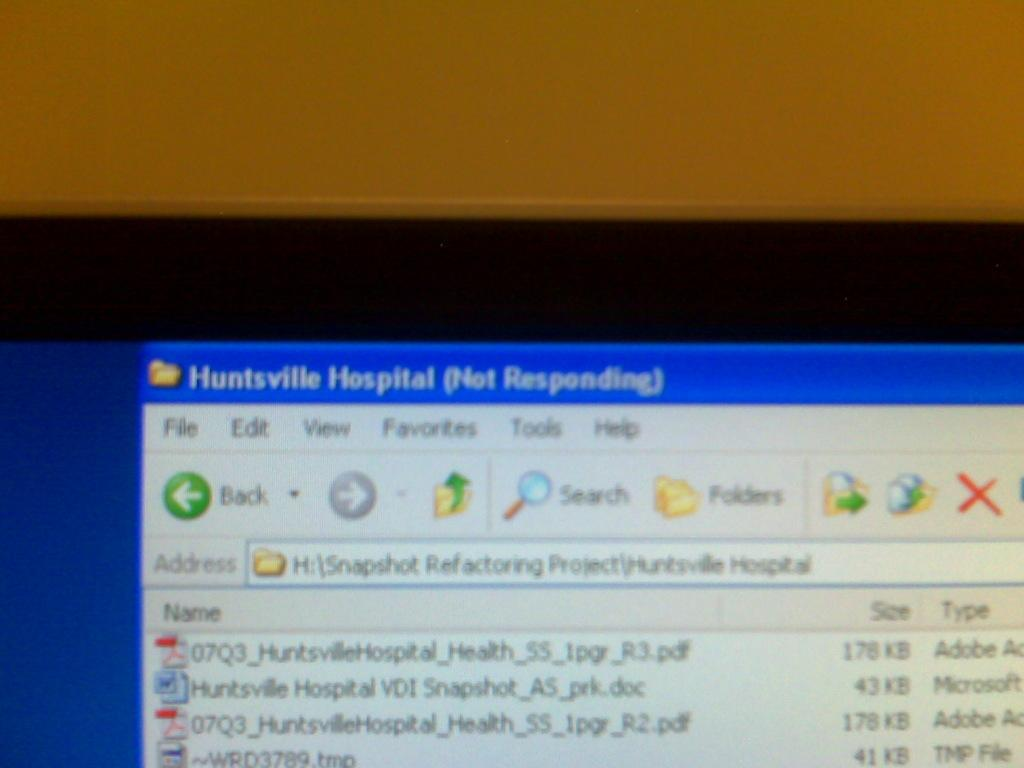<image>
Describe the image concisely. On the computer, Huntsville Hospital is not reponding. 